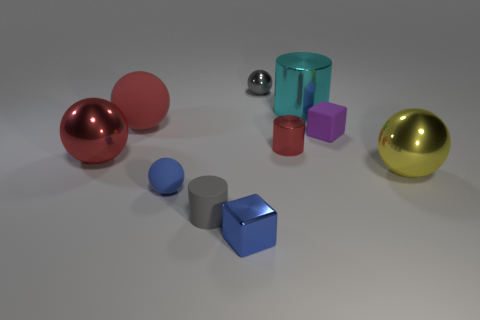How many big things are either yellow metallic spheres or cubes?
Provide a succinct answer. 1. What material is the blue object that is the same shape as the gray metallic object?
Offer a very short reply. Rubber. The small shiny block is what color?
Your response must be concise. Blue. Is the tiny matte cylinder the same color as the small metallic sphere?
Make the answer very short. Yes. There is a large red ball behind the red metal sphere; how many cyan cylinders are in front of it?
Provide a succinct answer. 0. What size is the matte thing that is behind the small blue rubber object and on the left side of the blue metallic thing?
Give a very brief answer. Large. What is the blue object that is behind the small gray rubber cylinder made of?
Keep it short and to the point. Rubber. Is there a yellow object of the same shape as the red matte object?
Give a very brief answer. Yes. How many purple rubber things are the same shape as the tiny blue metal object?
Give a very brief answer. 1. Do the red object that is right of the tiny gray cylinder and the blue metallic cube in front of the big cyan cylinder have the same size?
Offer a terse response. Yes. 